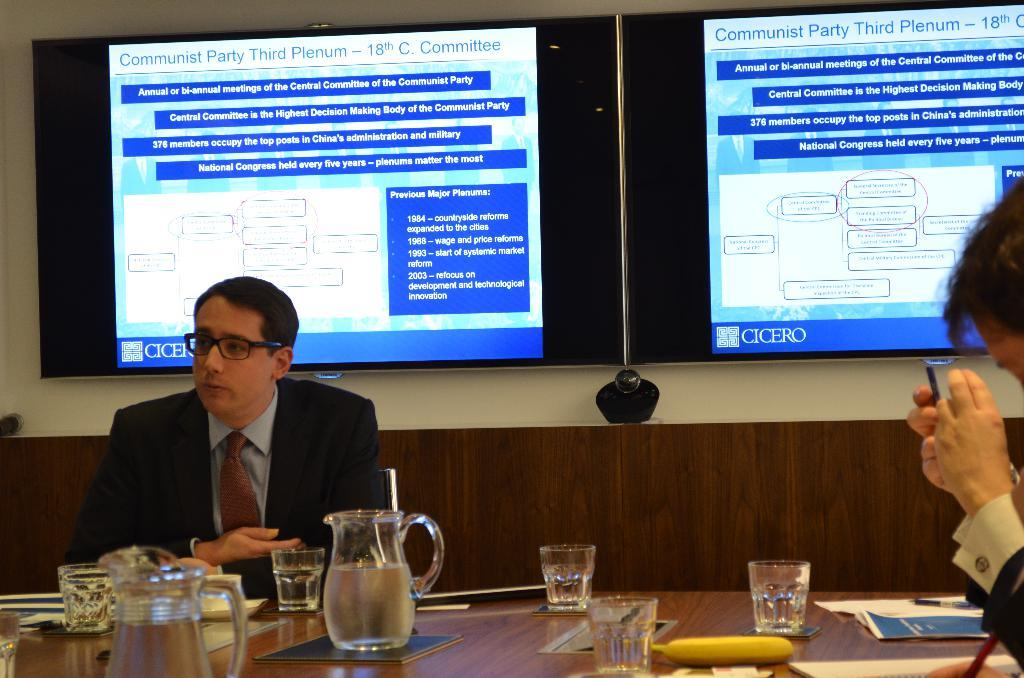<image>
Give a short and clear explanation of the subsequent image. A man in a suit is sitting under a screen that mentions the Communist Party. 